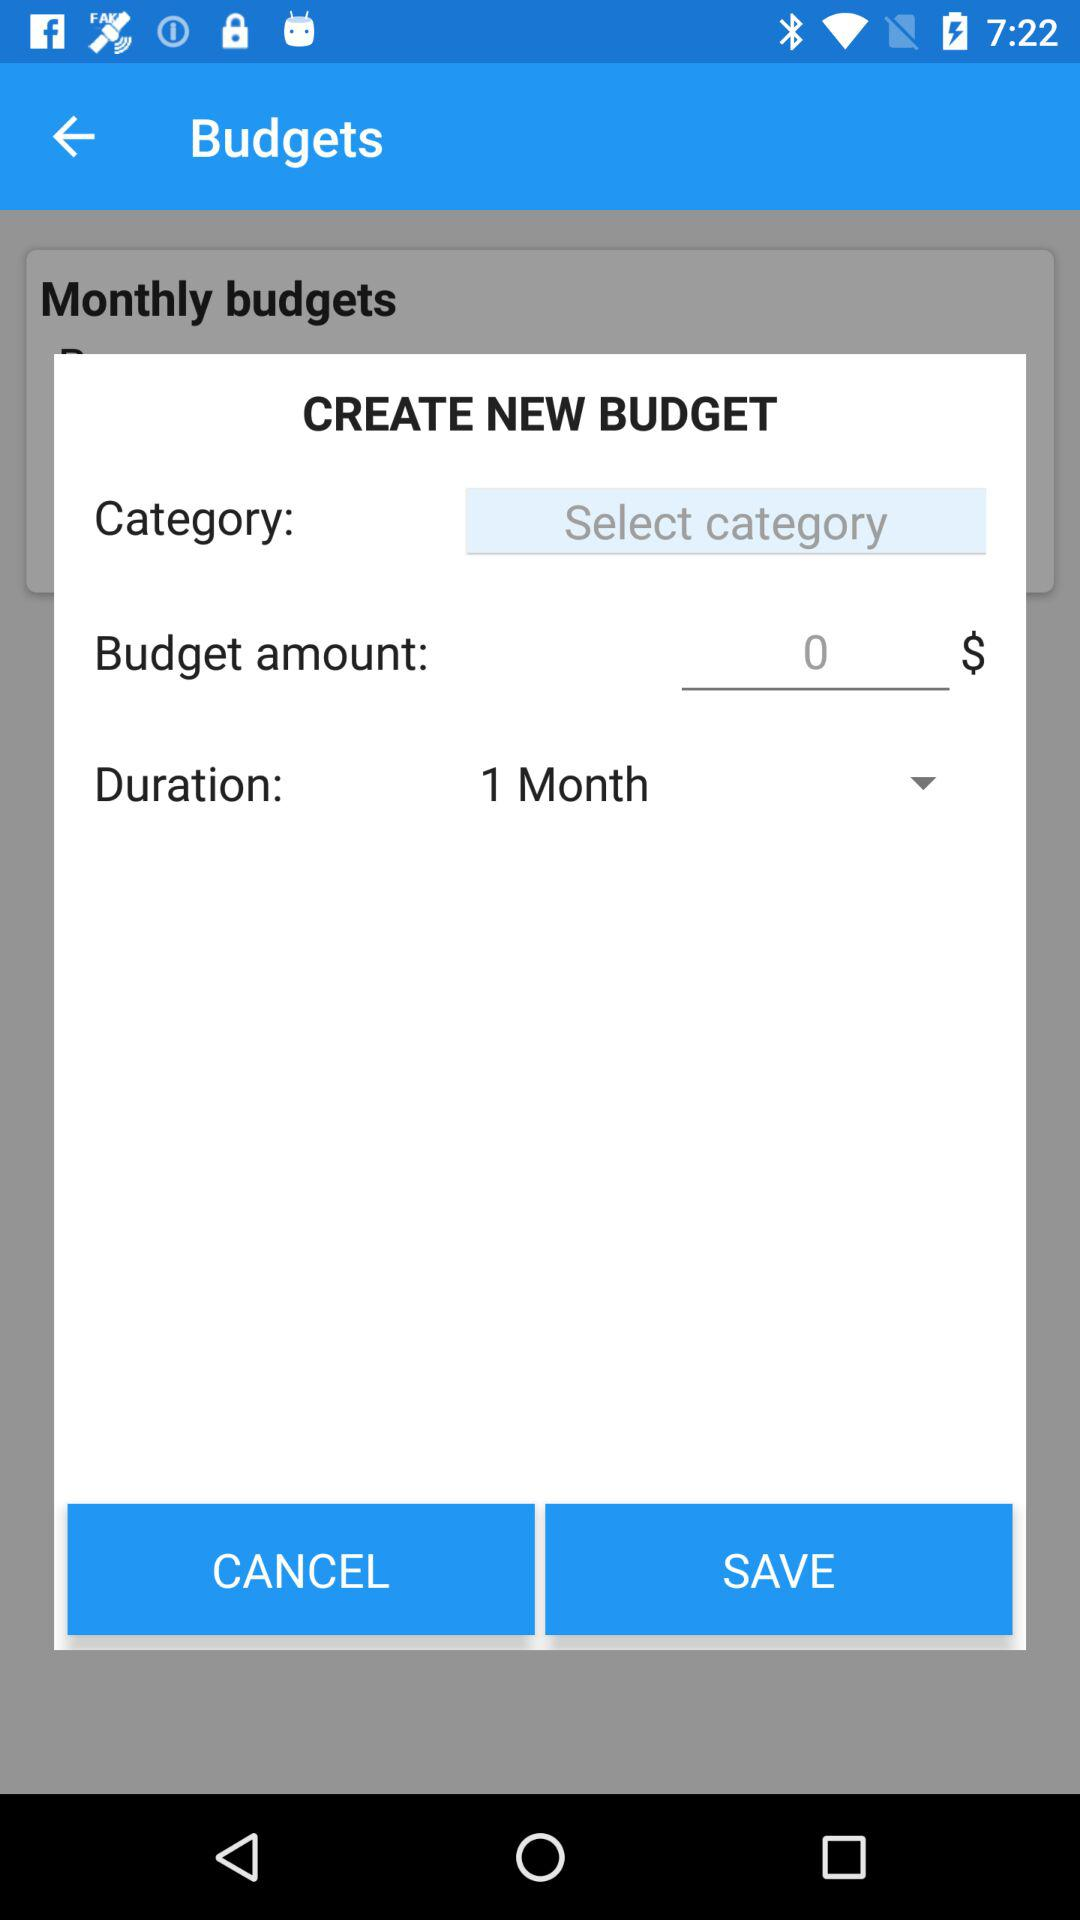How long is the duration in months?
Answer the question using a single word or phrase. 1 